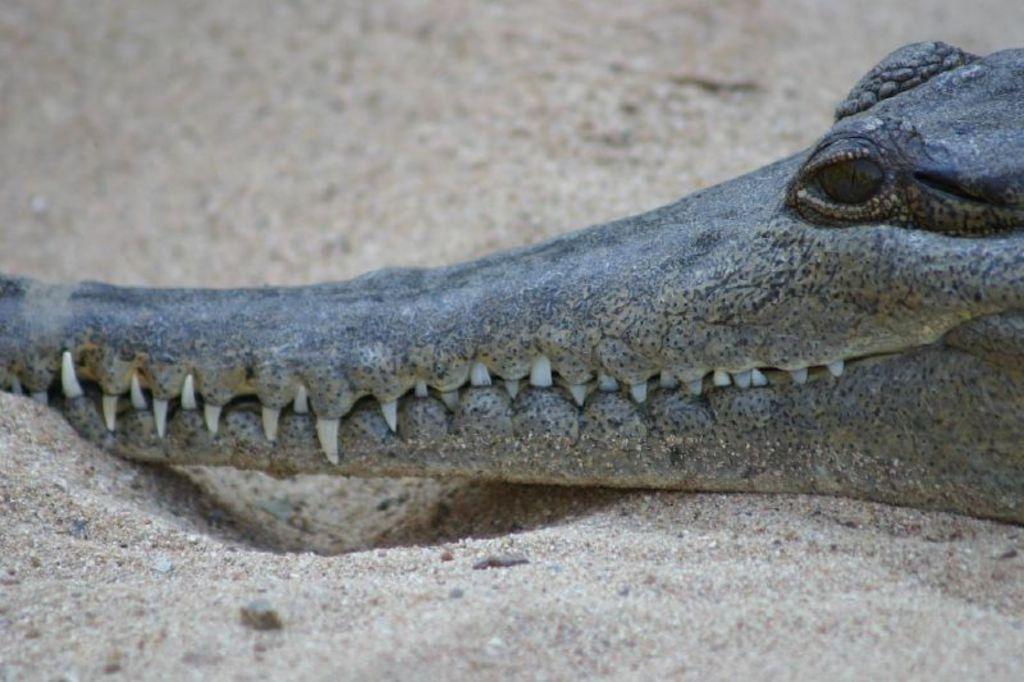Could you give a brief overview of what you see in this image? There is a crocodile on the sand. 